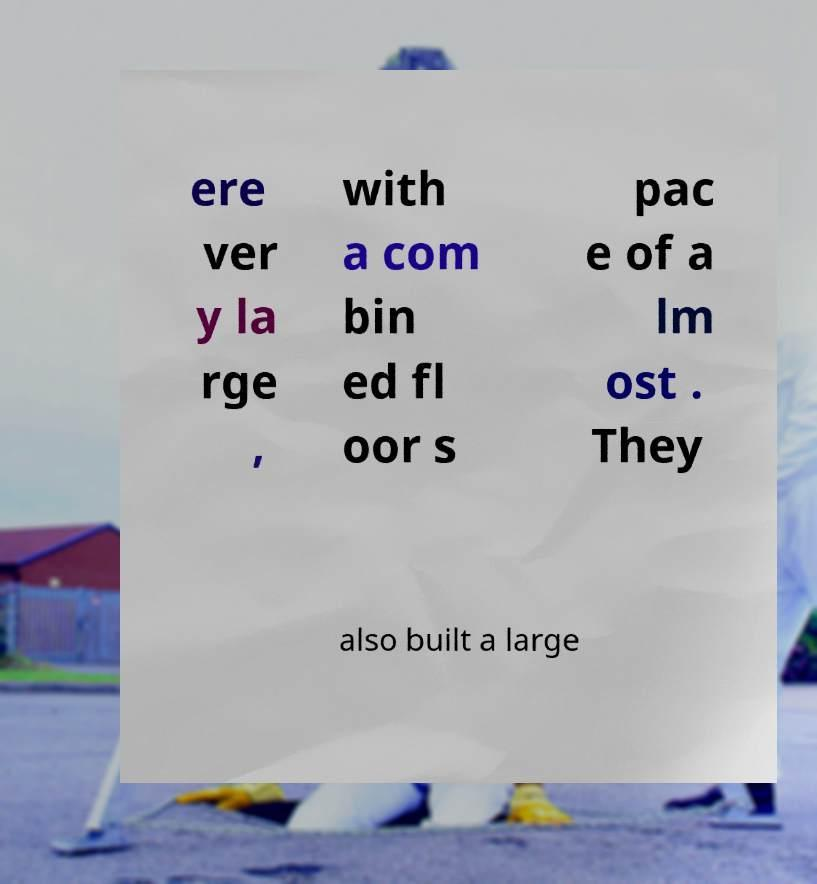Could you extract and type out the text from this image? ere ver y la rge , with a com bin ed fl oor s pac e of a lm ost . They also built a large 